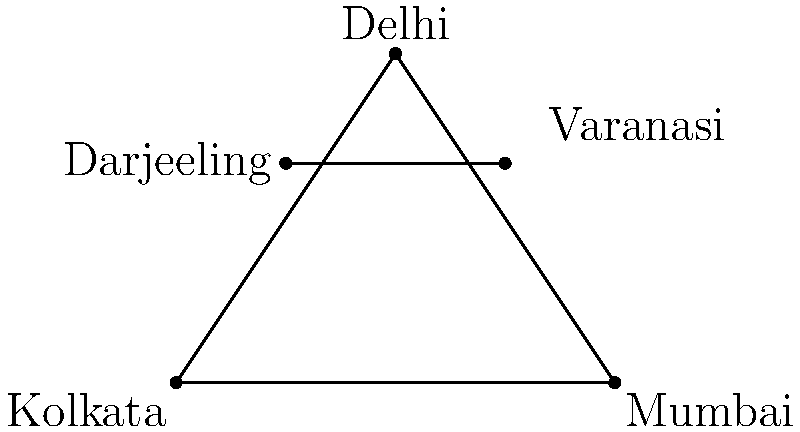In the diagram representing Roddur Roy's most popular video locations, what is the topological classification of the shape formed by connecting Kolkata, Mumbai, and Delhi? To determine the topological classification of the shape formed by connecting Kolkata, Mumbai, and Delhi, let's follow these steps:

1. Identify the points:
   - Kolkata is represented by point A
   - Mumbai is represented by point B
   - Delhi is represented by point C

2. Observe the connections:
   - These three points are connected by straight lines, forming a closed shape.

3. Analyze the shape:
   - The shape has three vertices (A, B, and C)
   - It has three edges (AB, BC, and CA)
   - The shape is closed and has no holes

4. Classify the shape:
   - A closed shape with three vertices and three edges, forming a single face, is topologically equivalent to a triangle.

5. Topological properties:
   - In topology, a triangle is homeomorphic to a circle, as it can be continuously deformed into a circle without breaking or creating new holes.

Therefore, the shape formed by connecting Kolkata, Mumbai, and Delhi is topologically classified as a simple closed curve, which is equivalent to a circle in topological terms.
Answer: Simple closed curve 